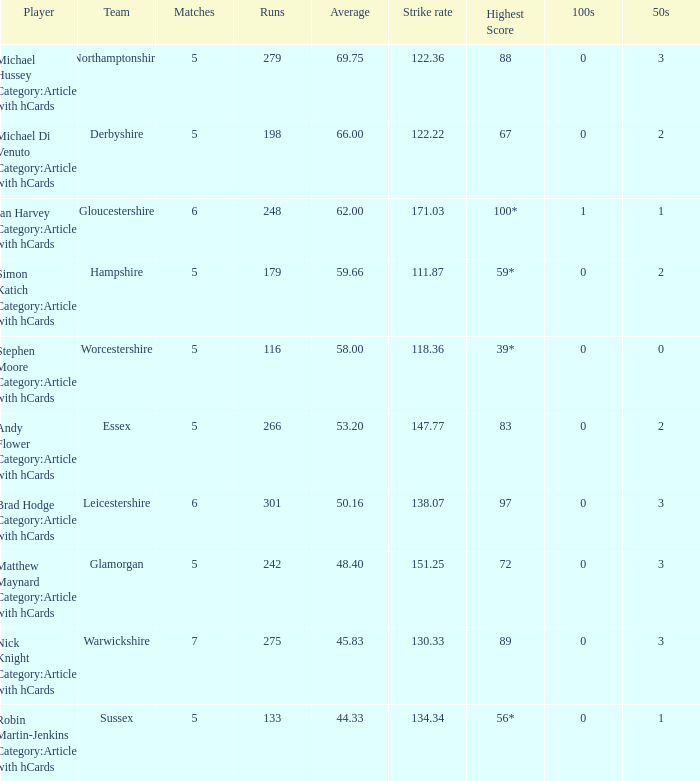If the average is 50.16, who is the player? Brad Hodge Category:Articles with hCards. 